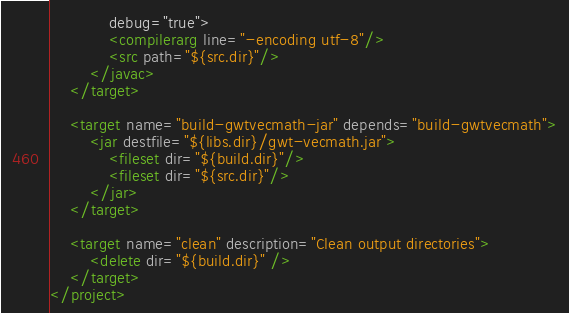<code> <loc_0><loc_0><loc_500><loc_500><_XML_>			debug="true">
			<compilerarg line="-encoding utf-8"/>
			<src path="${src.dir}"/>
		</javac>
	</target>

	<target name="build-gwtvecmath-jar" depends="build-gwtvecmath">
		<jar destfile="${libs.dir}/gwt-vecmath.jar">
			<fileset dir="${build.dir}"/>
			<fileset dir="${src.dir}"/>
		</jar>
	</target>
 
	<target name="clean" description="Clean output directories">
		<delete dir="${build.dir}" />
	</target>
</project>
</code> 